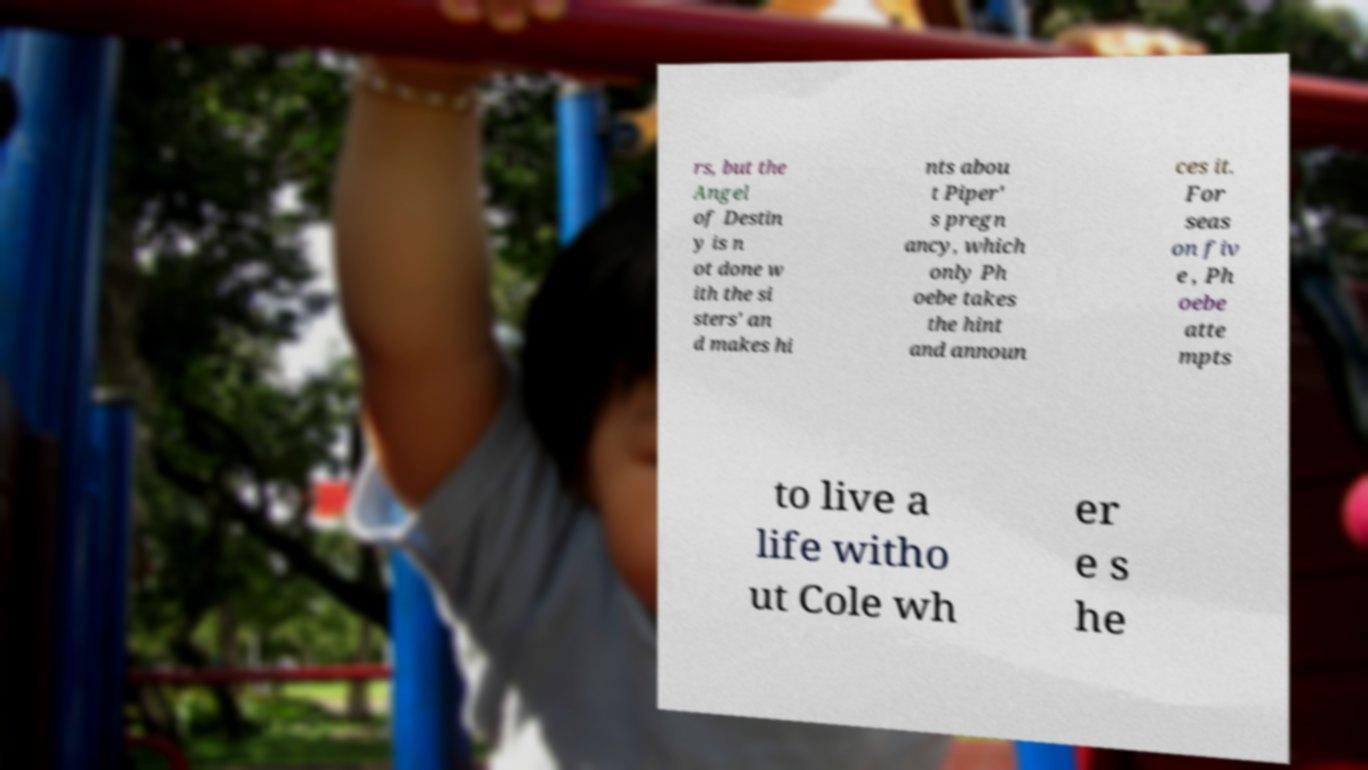Could you assist in decoding the text presented in this image and type it out clearly? rs, but the Angel of Destin y is n ot done w ith the si sters' an d makes hi nts abou t Piper' s pregn ancy, which only Ph oebe takes the hint and announ ces it. For seas on fiv e , Ph oebe atte mpts to live a life witho ut Cole wh er e s he 